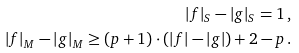<formula> <loc_0><loc_0><loc_500><loc_500>| f | _ { S } - | g | _ { S } = 1 \, , \\ | f | _ { M } - | g | _ { M } \geq ( p + 1 ) \cdot ( | f | - | g | ) + 2 - p \, .</formula> 